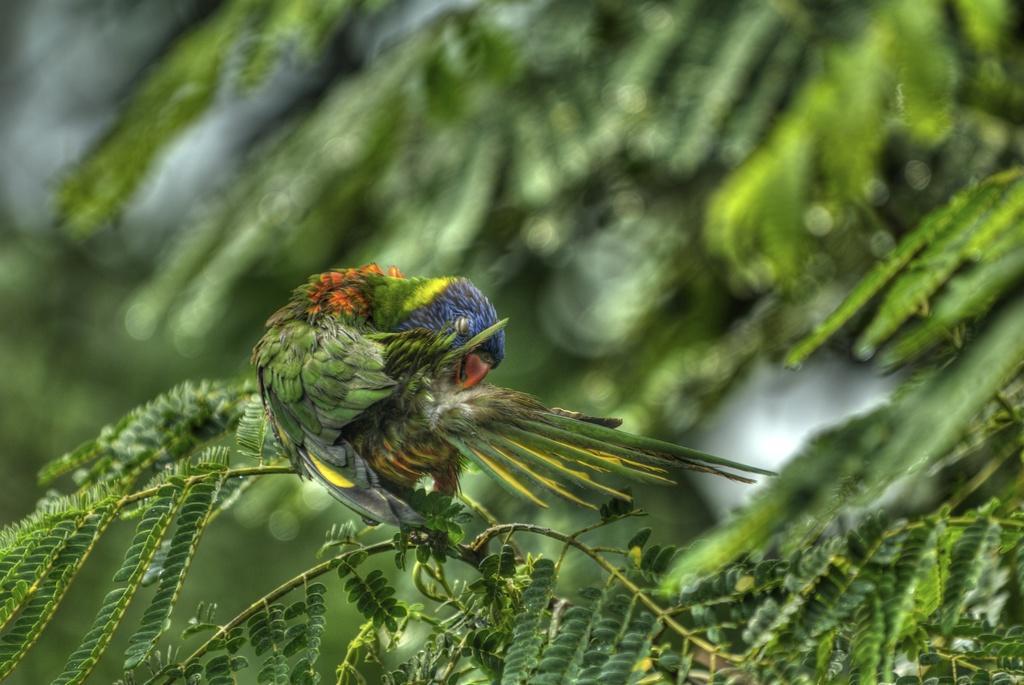Could you give a brief overview of what you see in this image? In this image, we can see a parrot. Here we can see leaves with stems. Background there is a blur view. 